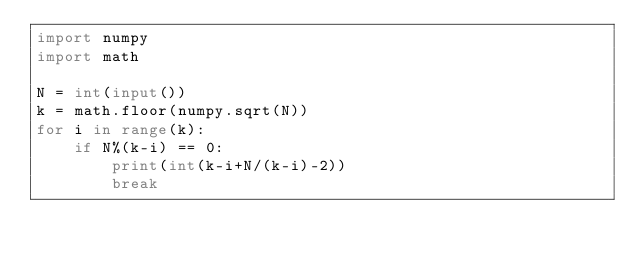Convert code to text. <code><loc_0><loc_0><loc_500><loc_500><_Python_>import numpy
import math

N = int(input())
k = math.floor(numpy.sqrt(N))
for i in range(k):
    if N%(k-i) == 0:
        print(int(k-i+N/(k-i)-2))
        break</code> 